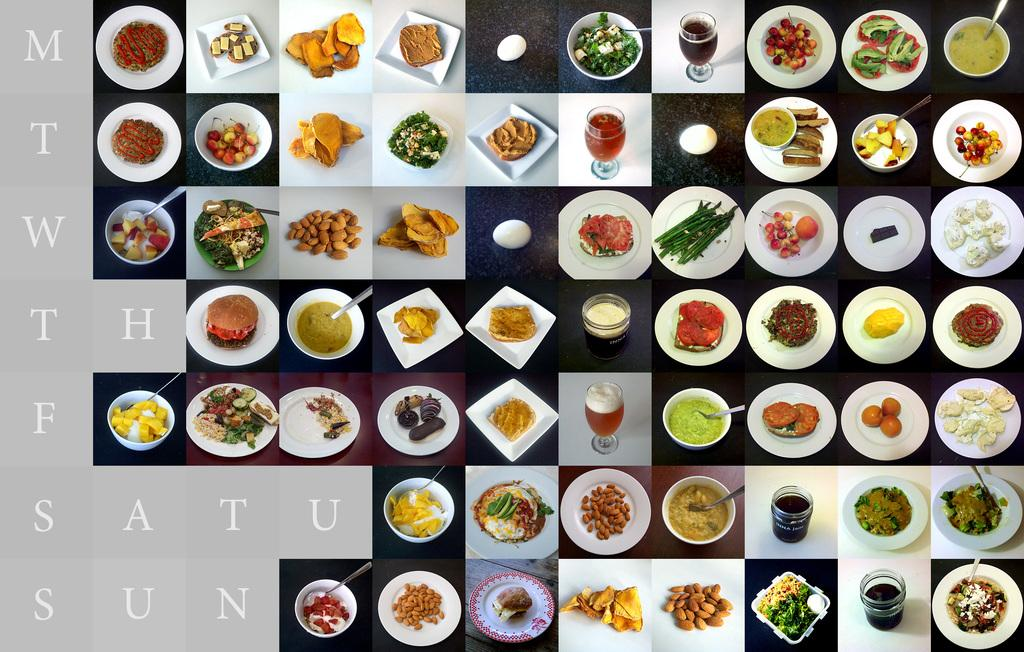What can be seen in the plate in the image? There are many food items in a plate in the image. Where is the text located in the image? The text is on the left side of the image. What type of plough is being used to harvest the food in the image? There is no plough present in the image; it features a plate of food items and text. 